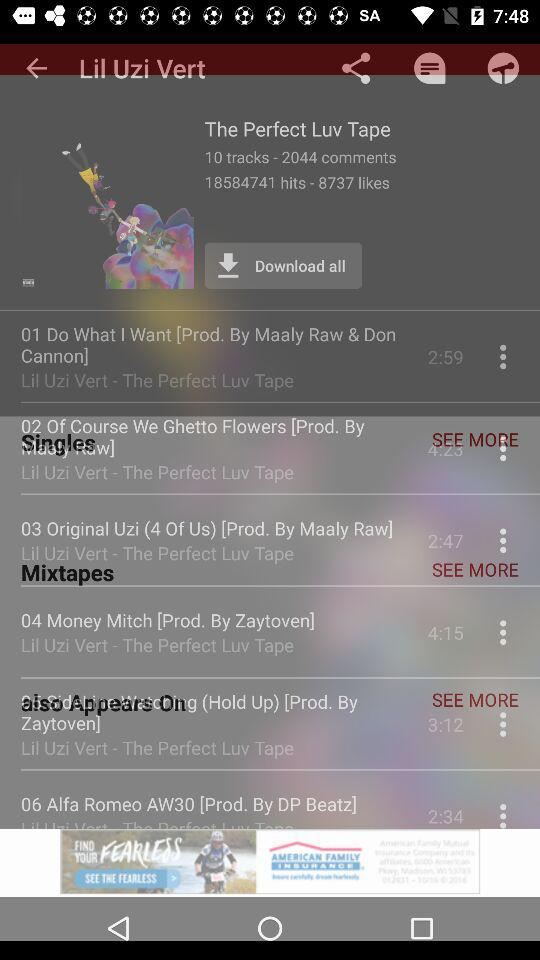How many comments did "The Perfect Luv Tape" get? "The Perfect Luv Tape" got 2044 comments. 